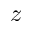Convert formula to latex. <formula><loc_0><loc_0><loc_500><loc_500>z</formula> 